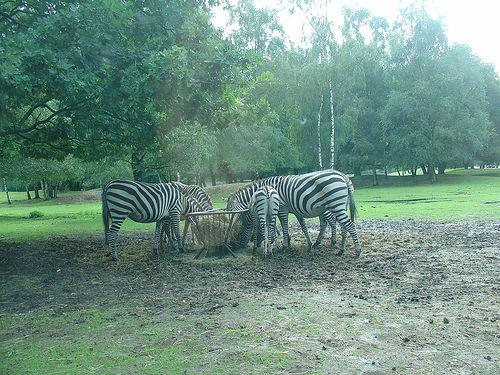Are these Zebras wild?
Be succinct. No. What are the animals in the photo doing?
Keep it brief. Eating. Is this animal living in a zoo or in nature?
Keep it brief. Zoo. How many weeds are in the field?
Short answer required. Lots. 